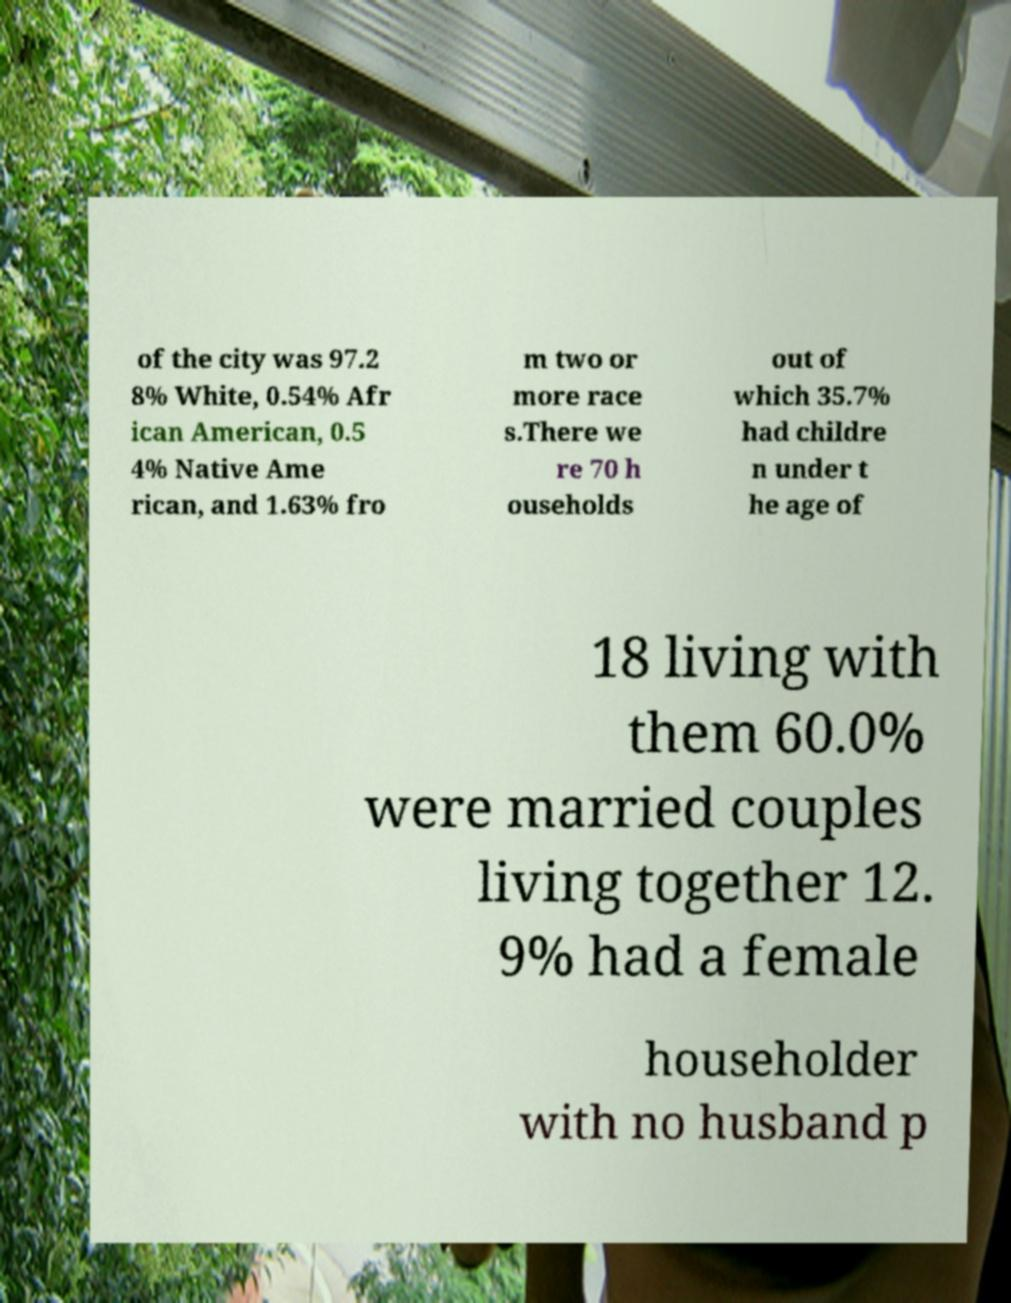Can you read and provide the text displayed in the image?This photo seems to have some interesting text. Can you extract and type it out for me? of the city was 97.2 8% White, 0.54% Afr ican American, 0.5 4% Native Ame rican, and 1.63% fro m two or more race s.There we re 70 h ouseholds out of which 35.7% had childre n under t he age of 18 living with them 60.0% were married couples living together 12. 9% had a female householder with no husband p 